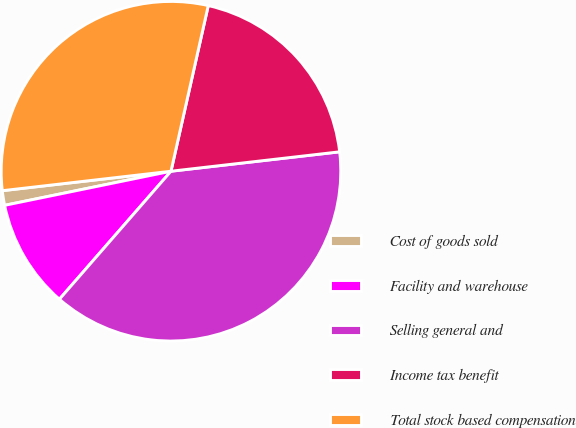Convert chart to OTSL. <chart><loc_0><loc_0><loc_500><loc_500><pie_chart><fcel>Cost of goods sold<fcel>Facility and warehouse<fcel>Selling general and<fcel>Income tax benefit<fcel>Total stock based compensation<nl><fcel>1.39%<fcel>10.37%<fcel>38.23%<fcel>19.65%<fcel>30.35%<nl></chart> 